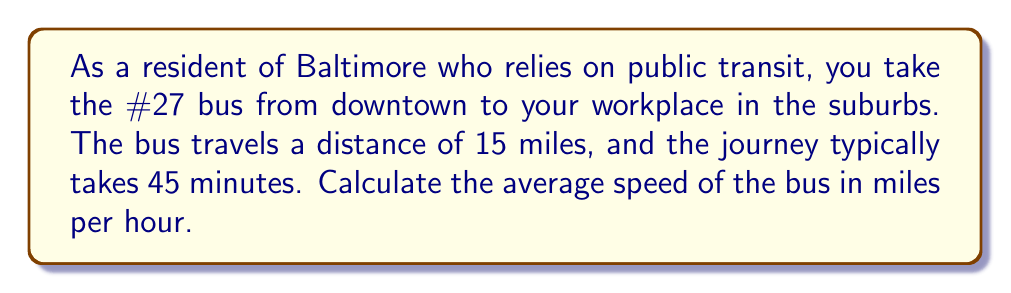Teach me how to tackle this problem. To solve this problem, we'll use the formula for average speed:

$$ \text{Average Speed} = \frac{\text{Distance}}{\text{Time}} $$

Given:
- Distance = 15 miles
- Time = 45 minutes

First, we need to convert the time from minutes to hours:
$$ 45 \text{ minutes} = \frac{45}{60} \text{ hours} = 0.75 \text{ hours} $$

Now, we can plug the values into the formula:

$$ \text{Average Speed} = \frac{15 \text{ miles}}{0.75 \text{ hours}} $$

Performing the division:

$$ \text{Average Speed} = 20 \text{ miles per hour} $$

Therefore, the average speed of the bus is 20 miles per hour.
Answer: $20 \text{ miles per hour}$ 